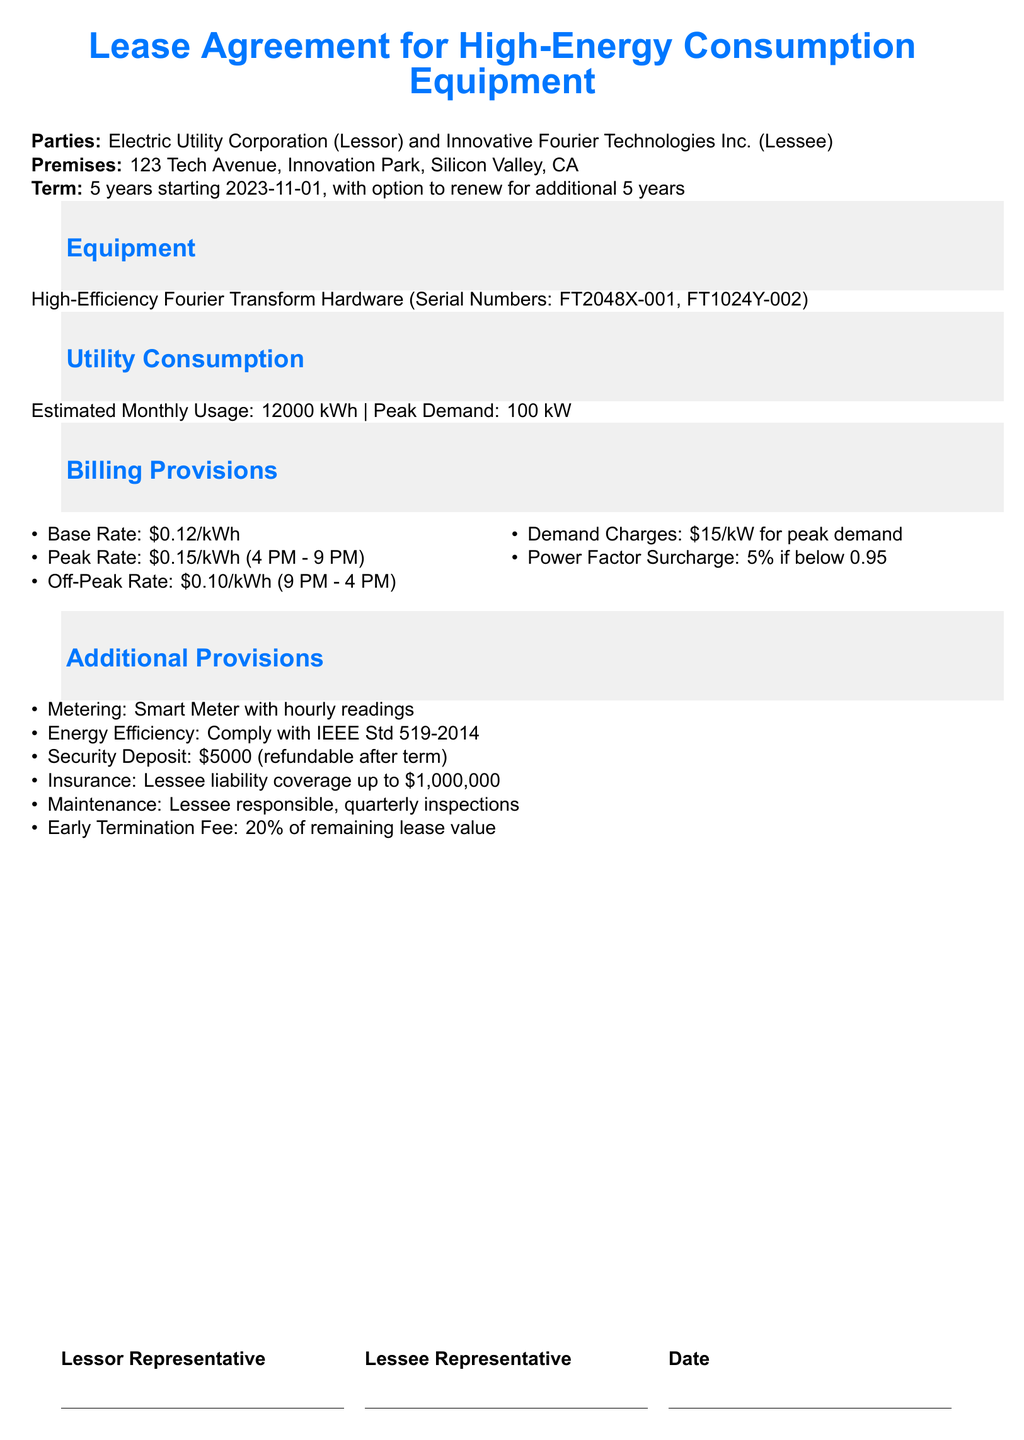What is the name of the lessor? The lessor is identified as Electric Utility Corporation in the document.
Answer: Electric Utility Corporation What is the estimated monthly usage? The estimated monthly usage for the equipment is specified in the document as 12,000 kWh.
Answer: 12,000 kWh What is the base rate per kWh? The document states the base rate for electricity consumption as $0.12 per kWh.
Answer: $0.12/kWh How long is the lease term? The lease term is outlined as 5 years in the document.
Answer: 5 years What is the amount of the security deposit? The security deposit required according to the document is $5,000.
Answer: $5,000 What is the early termination fee percentage? The document mentions that the early termination fee is 20% of the remaining lease value.
Answer: 20% What insurance coverage amount is specified for the lessee? The lessee's liability coverage is stated as up to $1,000,000 in the document.
Answer: $1,000,000 When does the peak rate apply? The document specifies that the peak rate applies from 4 PM to 9 PM.
Answer: 4 PM - 9 PM What is the power factor surcharge percentage? The document indicates a power factor surcharge of 5% if below 0.95.
Answer: 5% 